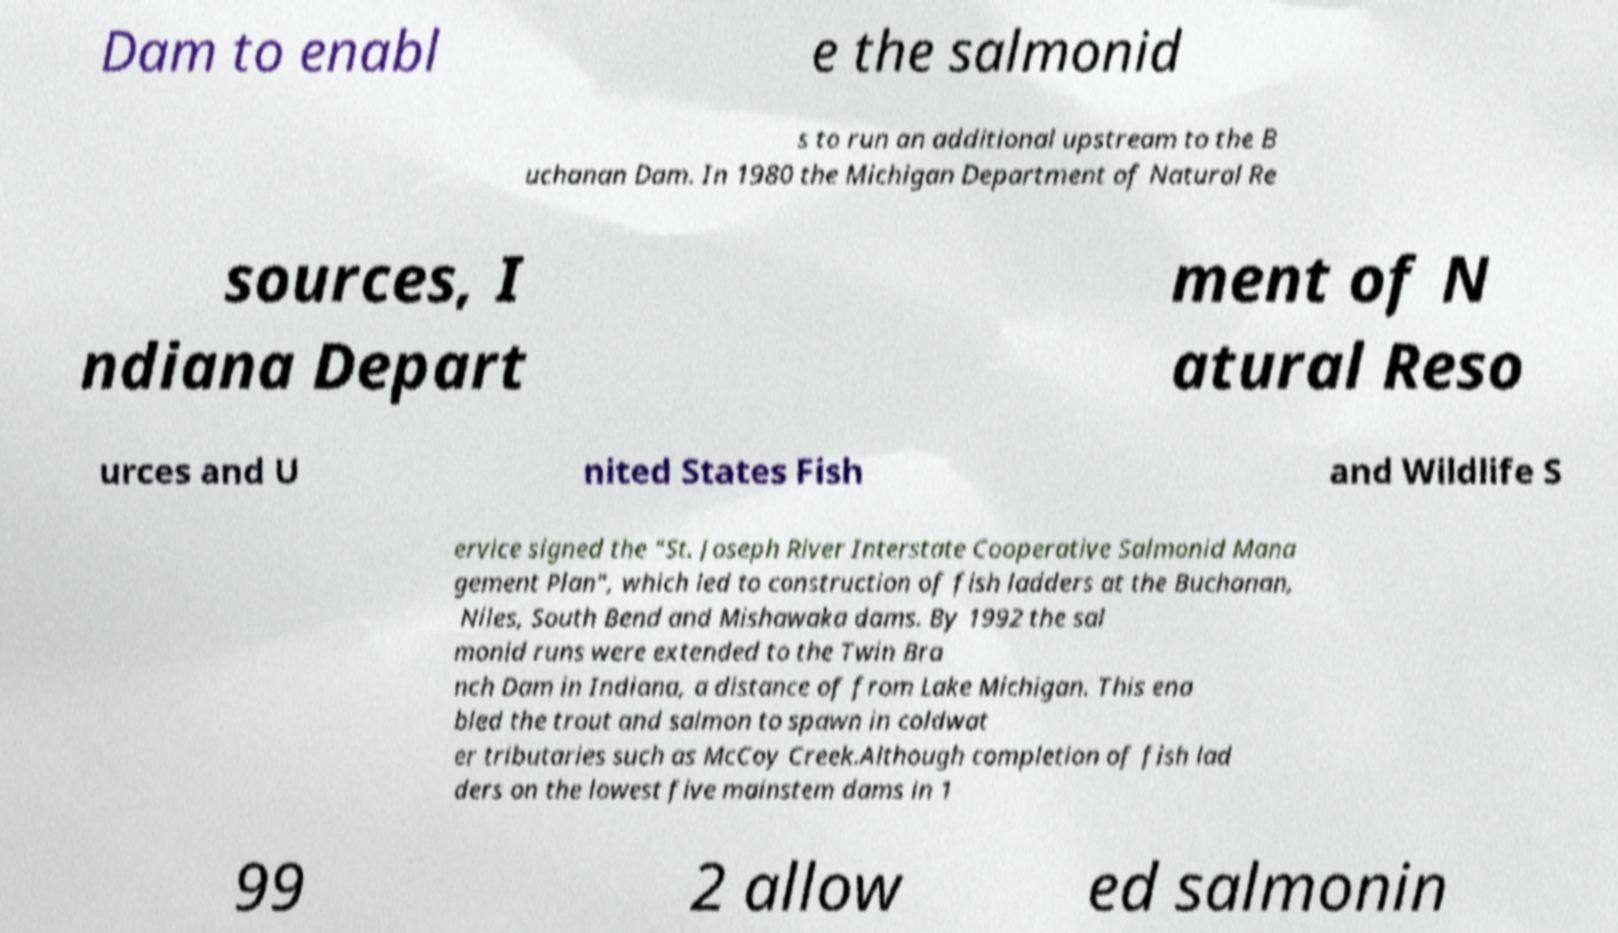Please read and relay the text visible in this image. What does it say? Dam to enabl e the salmonid s to run an additional upstream to the B uchanan Dam. In 1980 the Michigan Department of Natural Re sources, I ndiana Depart ment of N atural Reso urces and U nited States Fish and Wildlife S ervice signed the "St. Joseph River Interstate Cooperative Salmonid Mana gement Plan", which led to construction of fish ladders at the Buchanan, Niles, South Bend and Mishawaka dams. By 1992 the sal monid runs were extended to the Twin Bra nch Dam in Indiana, a distance of from Lake Michigan. This ena bled the trout and salmon to spawn in coldwat er tributaries such as McCoy Creek.Although completion of fish lad ders on the lowest five mainstem dams in 1 99 2 allow ed salmonin 